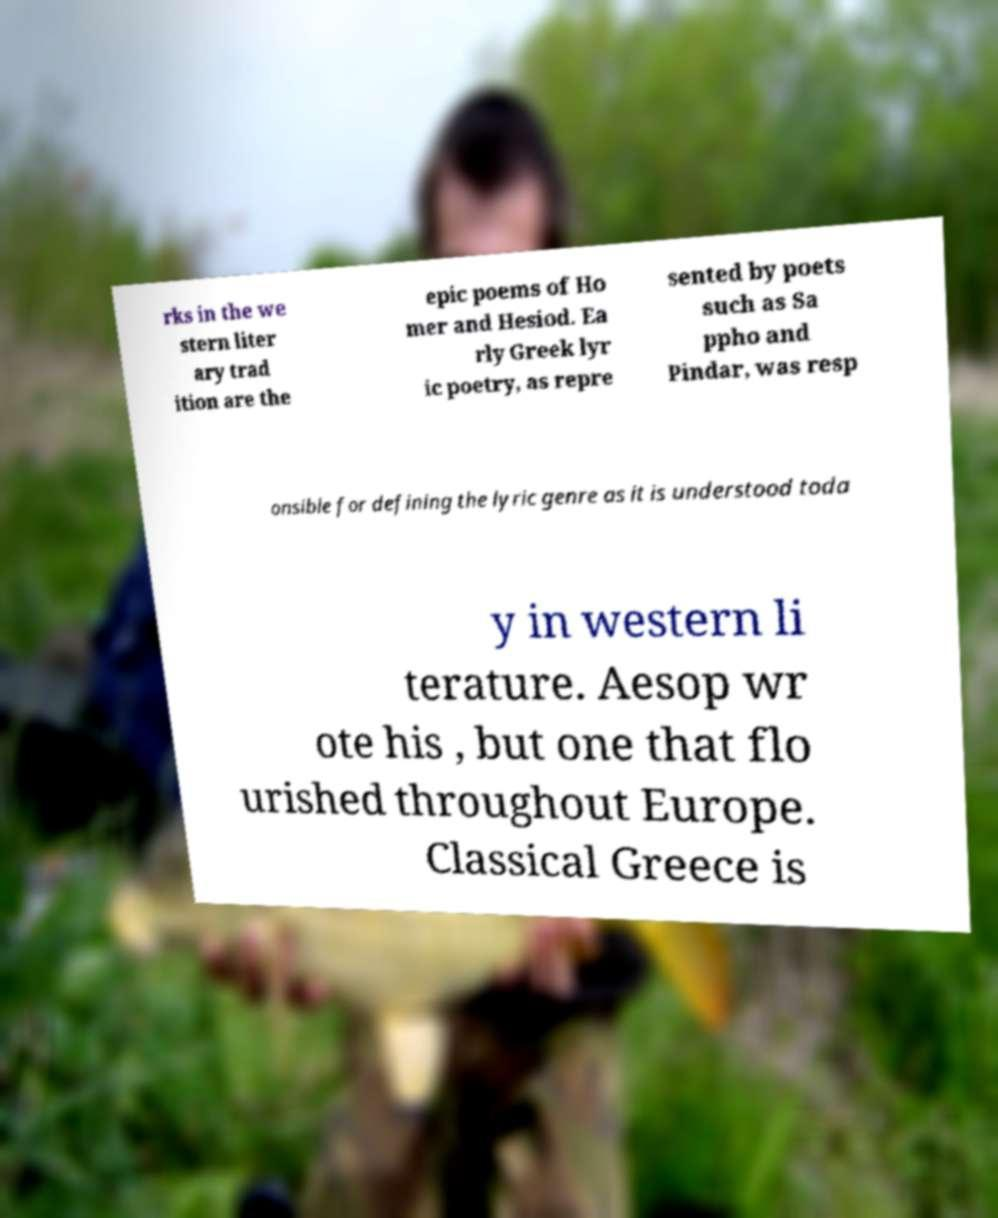Could you assist in decoding the text presented in this image and type it out clearly? rks in the we stern liter ary trad ition are the epic poems of Ho mer and Hesiod. Ea rly Greek lyr ic poetry, as repre sented by poets such as Sa ppho and Pindar, was resp onsible for defining the lyric genre as it is understood toda y in western li terature. Aesop wr ote his , but one that flo urished throughout Europe. Classical Greece is 